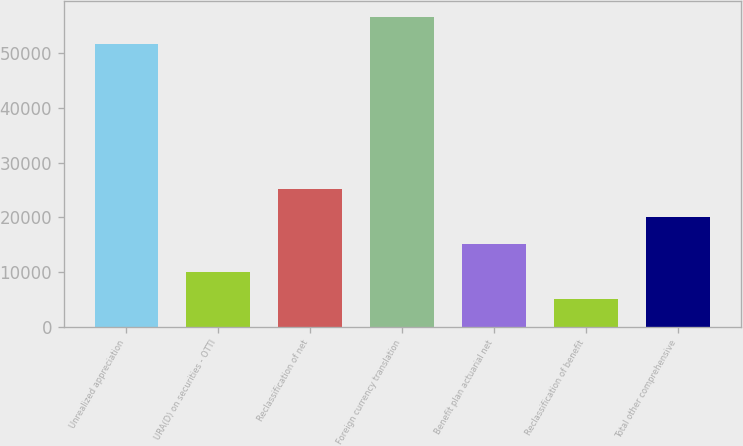<chart> <loc_0><loc_0><loc_500><loc_500><bar_chart><fcel>Unrealized appreciation<fcel>URA(D) on securities - OTTI<fcel>Reclassification of net<fcel>Foreign currency translation<fcel>Benefit plan actuarial net<fcel>Reclassification of benefit<fcel>Total other comprehensive<nl><fcel>51684<fcel>10099.8<fcel>25180.2<fcel>56710.8<fcel>15126.6<fcel>5073<fcel>20153.4<nl></chart> 